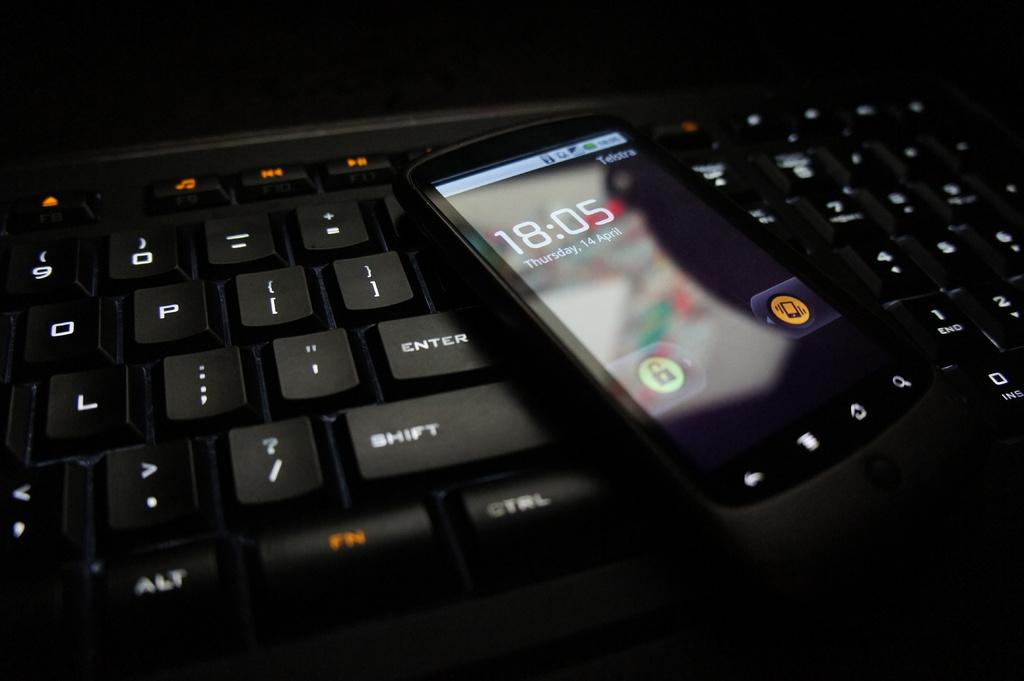<image>
Give a short and clear explanation of the subsequent image. A black phone shows the time as 18:05 on Thursday the 14th of April. 